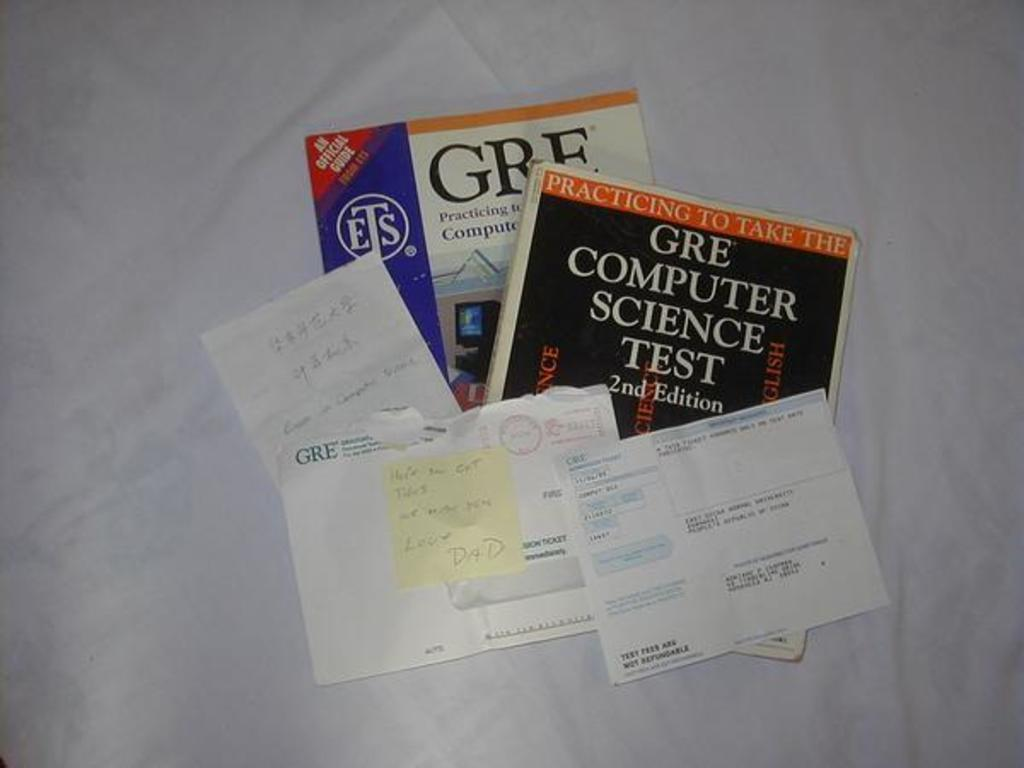<image>
Create a compact narrative representing the image presented. Several sheets of paperwork lie atop two GRE test prep books. 